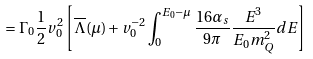Convert formula to latex. <formula><loc_0><loc_0><loc_500><loc_500>= \Gamma _ { 0 } \frac { 1 } { 2 } v _ { 0 } ^ { 2 } \left [ \overline { \Lambda } ( \mu ) + v _ { 0 } ^ { - 2 } \int _ { 0 } ^ { E _ { 0 } - \mu } \frac { 1 6 \alpha _ { s } } { 9 \pi } \frac { E ^ { 3 } } { E _ { 0 } m _ { Q } ^ { 2 } } d E \right ]</formula> 